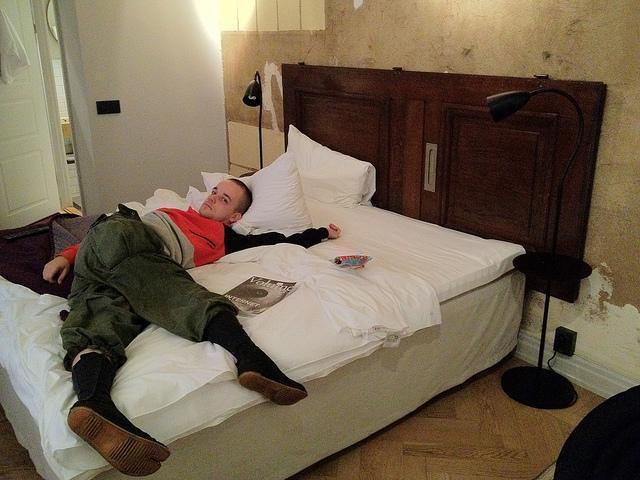How many pillows are on the bed?
Give a very brief answer. 2. 